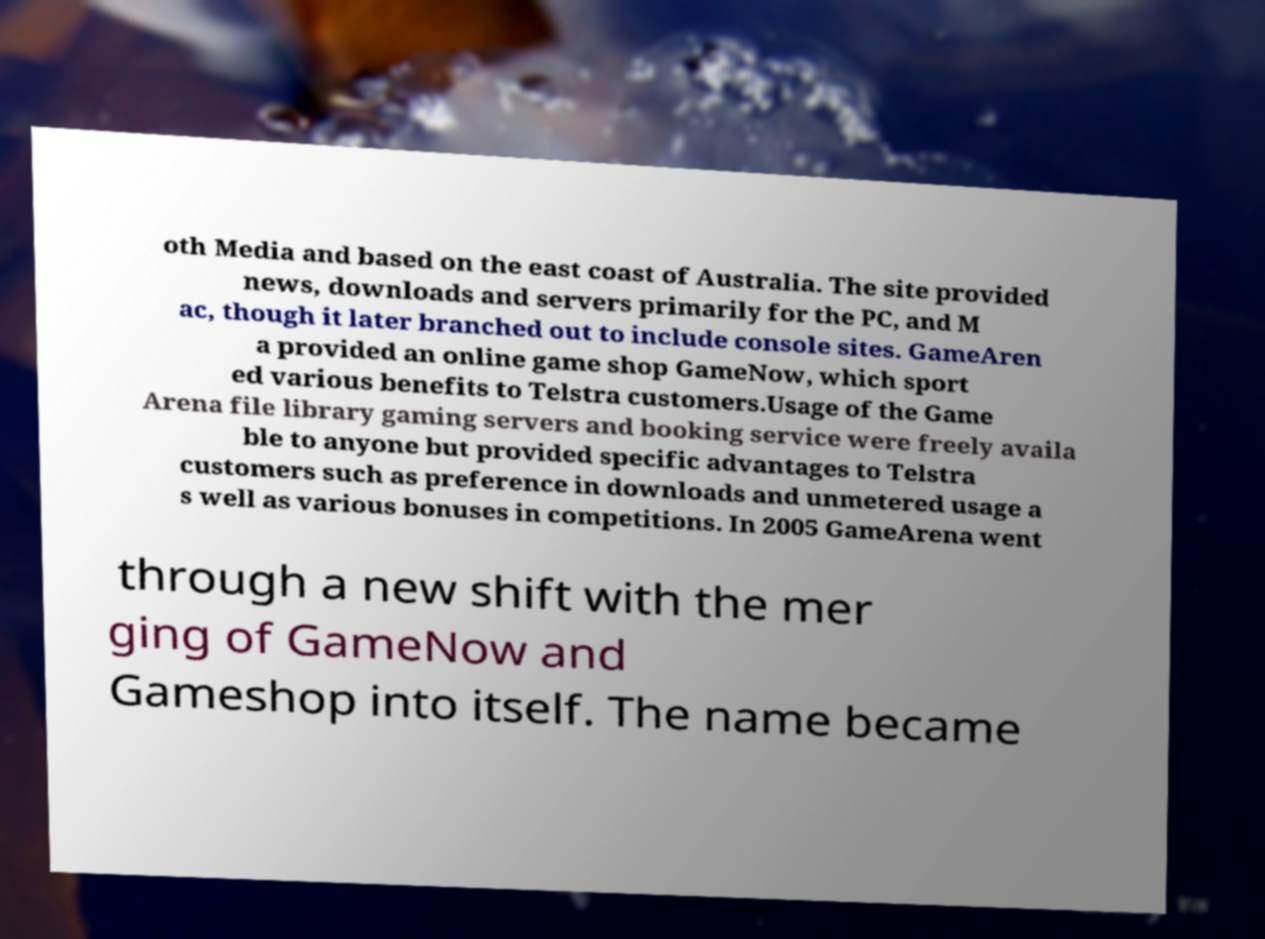Please identify and transcribe the text found in this image. oth Media and based on the east coast of Australia. The site provided news, downloads and servers primarily for the PC, and M ac, though it later branched out to include console sites. GameAren a provided an online game shop GameNow, which sport ed various benefits to Telstra customers.Usage of the Game Arena file library gaming servers and booking service were freely availa ble to anyone but provided specific advantages to Telstra customers such as preference in downloads and unmetered usage a s well as various bonuses in competitions. In 2005 GameArena went through a new shift with the mer ging of GameNow and Gameshop into itself. The name became 